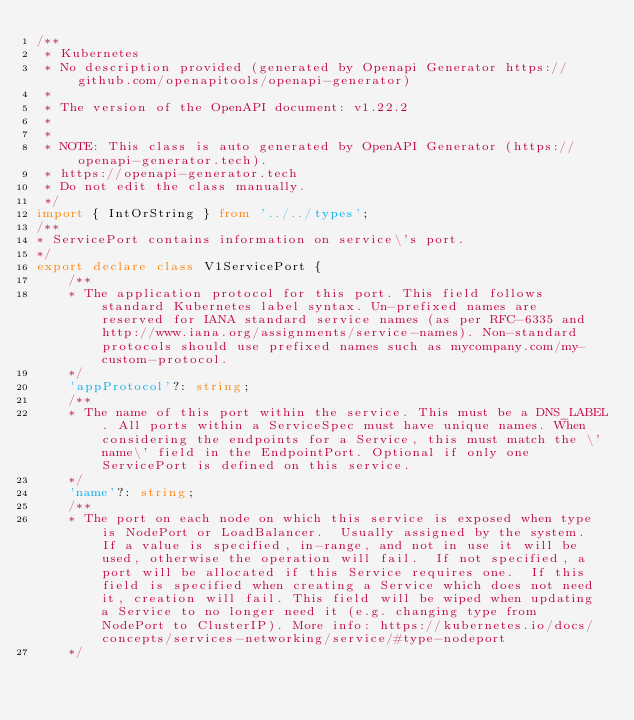<code> <loc_0><loc_0><loc_500><loc_500><_TypeScript_>/**
 * Kubernetes
 * No description provided (generated by Openapi Generator https://github.com/openapitools/openapi-generator)
 *
 * The version of the OpenAPI document: v1.22.2
 *
 *
 * NOTE: This class is auto generated by OpenAPI Generator (https://openapi-generator.tech).
 * https://openapi-generator.tech
 * Do not edit the class manually.
 */
import { IntOrString } from '../../types';
/**
* ServicePort contains information on service\'s port.
*/
export declare class V1ServicePort {
    /**
    * The application protocol for this port. This field follows standard Kubernetes label syntax. Un-prefixed names are reserved for IANA standard service names (as per RFC-6335 and http://www.iana.org/assignments/service-names). Non-standard protocols should use prefixed names such as mycompany.com/my-custom-protocol.
    */
    'appProtocol'?: string;
    /**
    * The name of this port within the service. This must be a DNS_LABEL. All ports within a ServiceSpec must have unique names. When considering the endpoints for a Service, this must match the \'name\' field in the EndpointPort. Optional if only one ServicePort is defined on this service.
    */
    'name'?: string;
    /**
    * The port on each node on which this service is exposed when type is NodePort or LoadBalancer.  Usually assigned by the system. If a value is specified, in-range, and not in use it will be used, otherwise the operation will fail.  If not specified, a port will be allocated if this Service requires one.  If this field is specified when creating a Service which does not need it, creation will fail. This field will be wiped when updating a Service to no longer need it (e.g. changing type from NodePort to ClusterIP). More info: https://kubernetes.io/docs/concepts/services-networking/service/#type-nodeport
    */</code> 